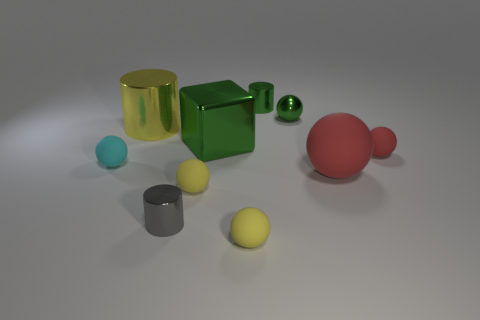Subtract all green cylinders. How many cylinders are left? 2 Subtract all brown cubes. How many red spheres are left? 2 Subtract 2 balls. How many balls are left? 4 Subtract all green balls. How many balls are left? 5 Subtract all cubes. How many objects are left? 9 Subtract 1 green cubes. How many objects are left? 9 Subtract all green balls. Subtract all gray cubes. How many balls are left? 5 Subtract all tiny yellow objects. Subtract all tiny green balls. How many objects are left? 7 Add 1 red objects. How many red objects are left? 3 Add 7 yellow metallic cylinders. How many yellow metallic cylinders exist? 8 